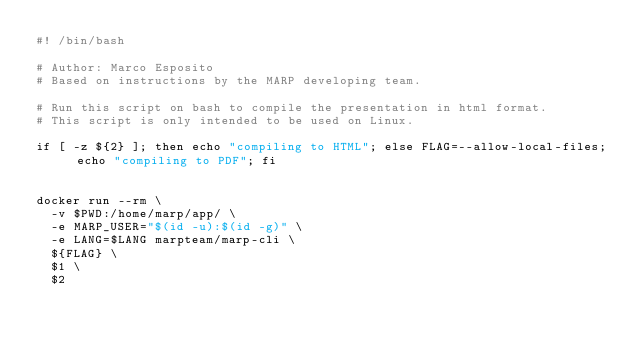Convert code to text. <code><loc_0><loc_0><loc_500><loc_500><_Bash_>#! /bin/bash

# Author: Marco Esposito
# Based on instructions by the MARP developing team.

# Run this script on bash to compile the presentation in html format.
# This script is only intended to be used on Linux.

if [ -z ${2} ]; then echo "compiling to HTML"; else FLAG=--allow-local-files; echo "compiling to PDF"; fi


docker run --rm \
	-v $PWD:/home/marp/app/ \
	-e MARP_USER="$(id -u):$(id -g)" \
	-e LANG=$LANG marpteam/marp-cli \
	${FLAG} \
	$1 \
	$2</code> 